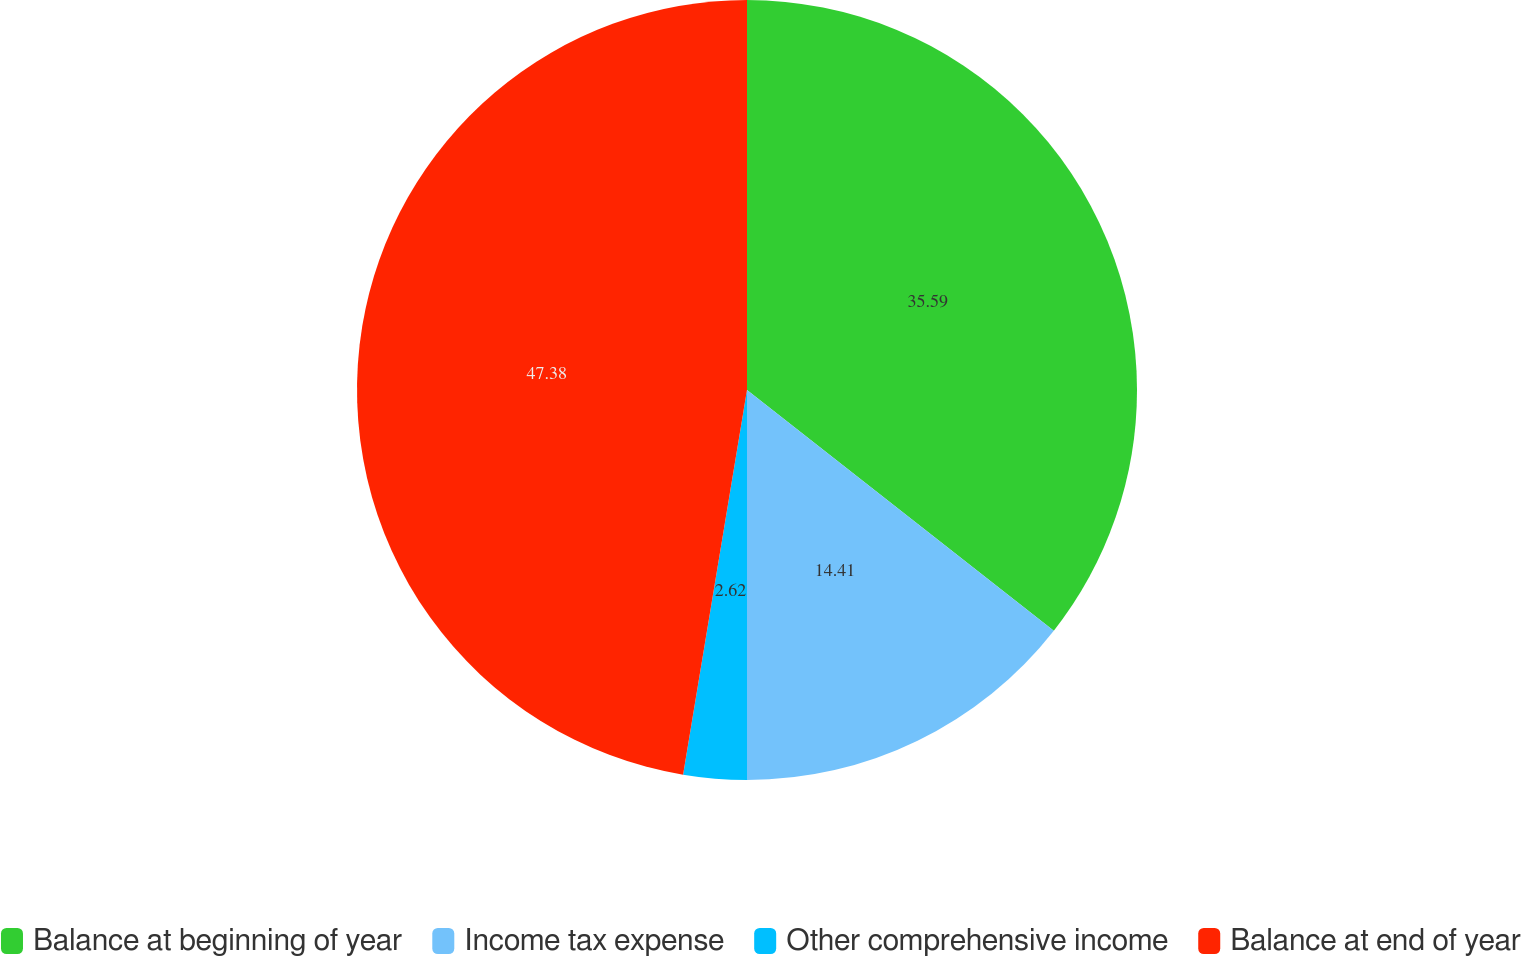Convert chart to OTSL. <chart><loc_0><loc_0><loc_500><loc_500><pie_chart><fcel>Balance at beginning of year<fcel>Income tax expense<fcel>Other comprehensive income<fcel>Balance at end of year<nl><fcel>35.59%<fcel>14.41%<fcel>2.62%<fcel>47.38%<nl></chart> 